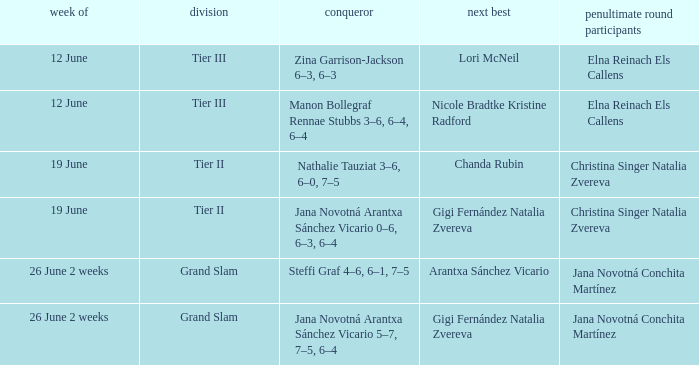Who reached the semi-finals when gigi fernández natalia zvereva were the second-place finishers during the 2-week period beginning on june 26? Jana Novotná Conchita Martínez. 